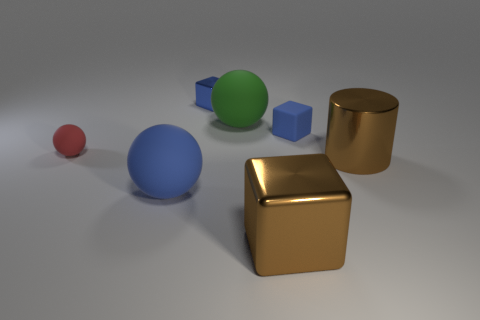How many large rubber balls are the same color as the small metallic thing?
Provide a short and direct response. 1. How many other objects are there of the same color as the cylinder?
Ensure brevity in your answer.  1. Is there anything else that is the same size as the green matte thing?
Your response must be concise. Yes. How many small matte spheres are on the left side of the big metal cylinder?
Your response must be concise. 1. Does the shiny block in front of the red object have the same size as the brown cylinder?
Your answer should be compact. Yes. What color is the tiny thing that is the same shape as the big blue thing?
Offer a terse response. Red. Is there any other thing that is the same shape as the small blue rubber object?
Ensure brevity in your answer.  Yes. What shape is the large metal thing behind the brown cube?
Offer a terse response. Cylinder. How many large matte objects are the same shape as the tiny red matte object?
Make the answer very short. 2. There is a matte object right of the big cube; is it the same color as the metal block that is to the right of the large green object?
Your answer should be compact. No. 